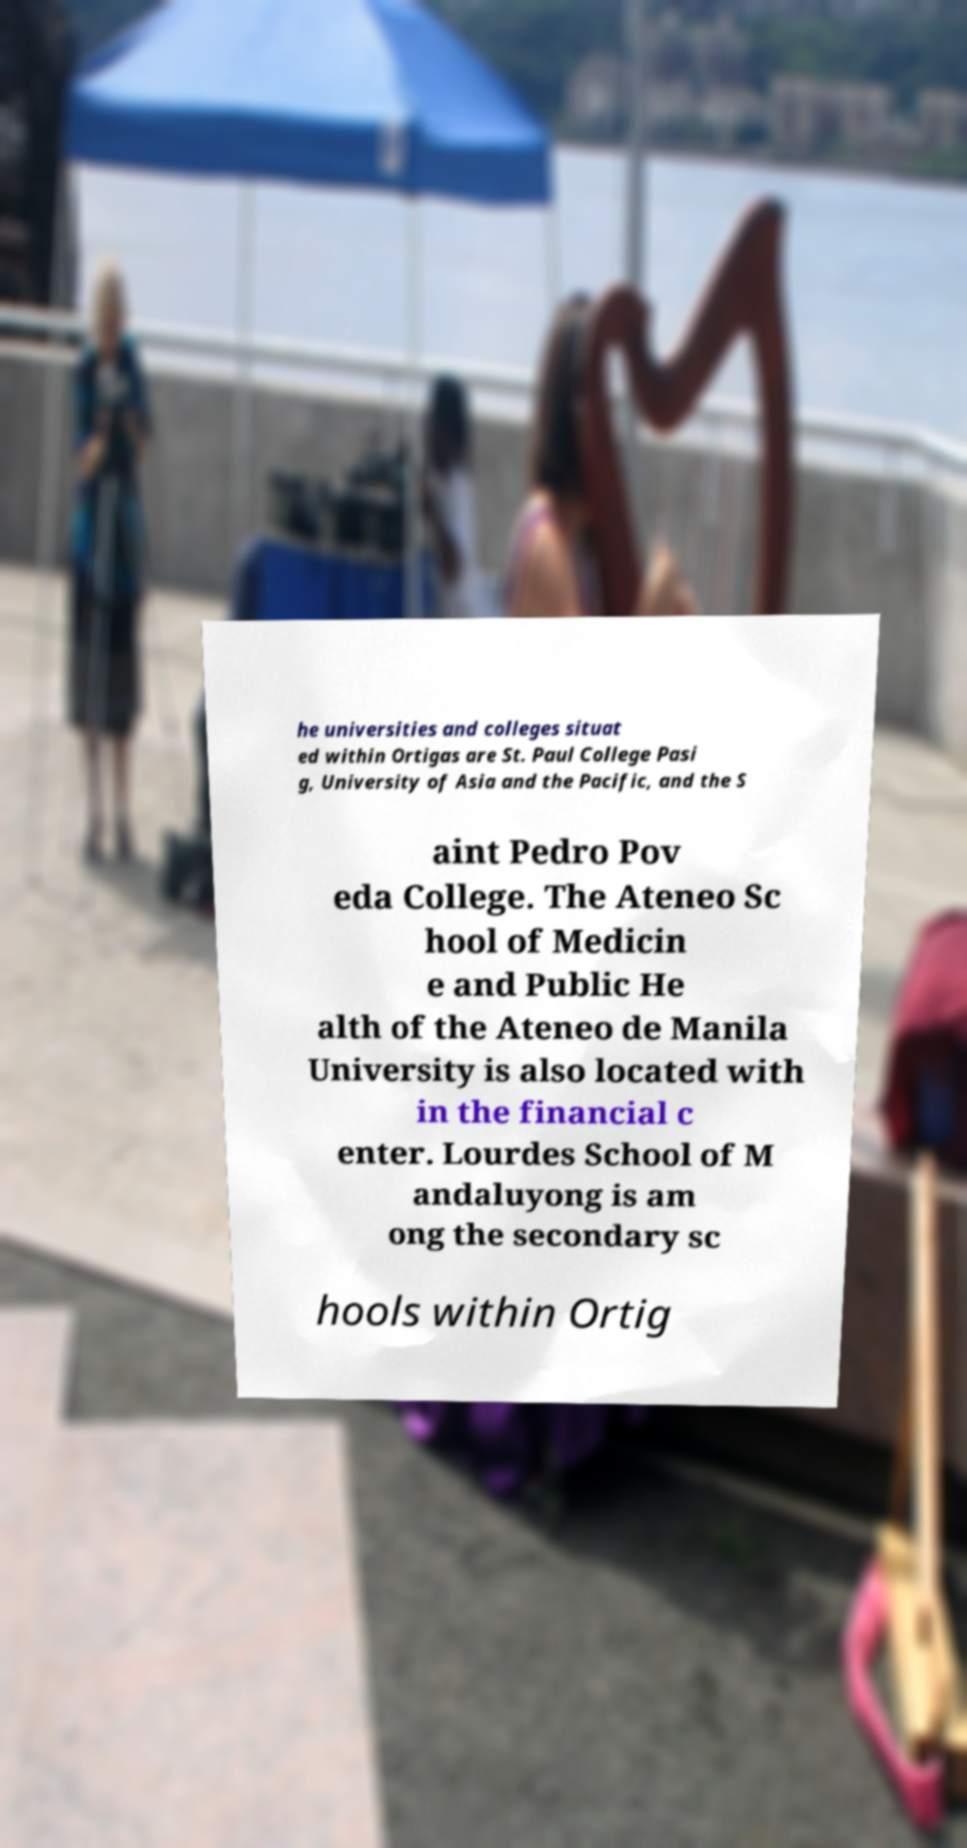Can you read and provide the text displayed in the image?This photo seems to have some interesting text. Can you extract and type it out for me? he universities and colleges situat ed within Ortigas are St. Paul College Pasi g, University of Asia and the Pacific, and the S aint Pedro Pov eda College. The Ateneo Sc hool of Medicin e and Public He alth of the Ateneo de Manila University is also located with in the financial c enter. Lourdes School of M andaluyong is am ong the secondary sc hools within Ortig 